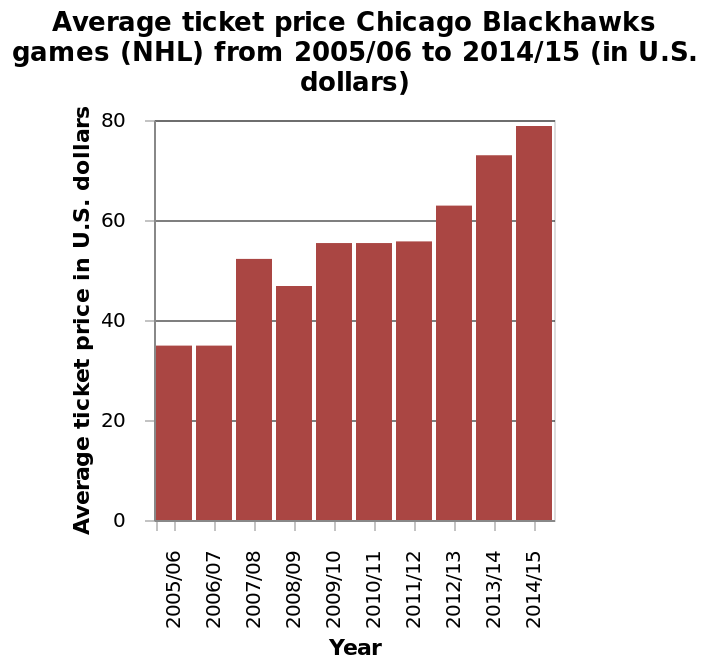<image>
What does each bar in the plot represent? Each bar in the plot represents the average ticket price for a specific year. What is the range of years represented in the bar plot? The range of years represented in the bar plot is from 2005/06 to 2014/15. Did the average ticket price increase or decrease in 2008/09?  The average ticket price decreased in 2008/09. What does the y-axis show in the bar plot? The y-axis shows the average ticket price in U.S. dollars. 